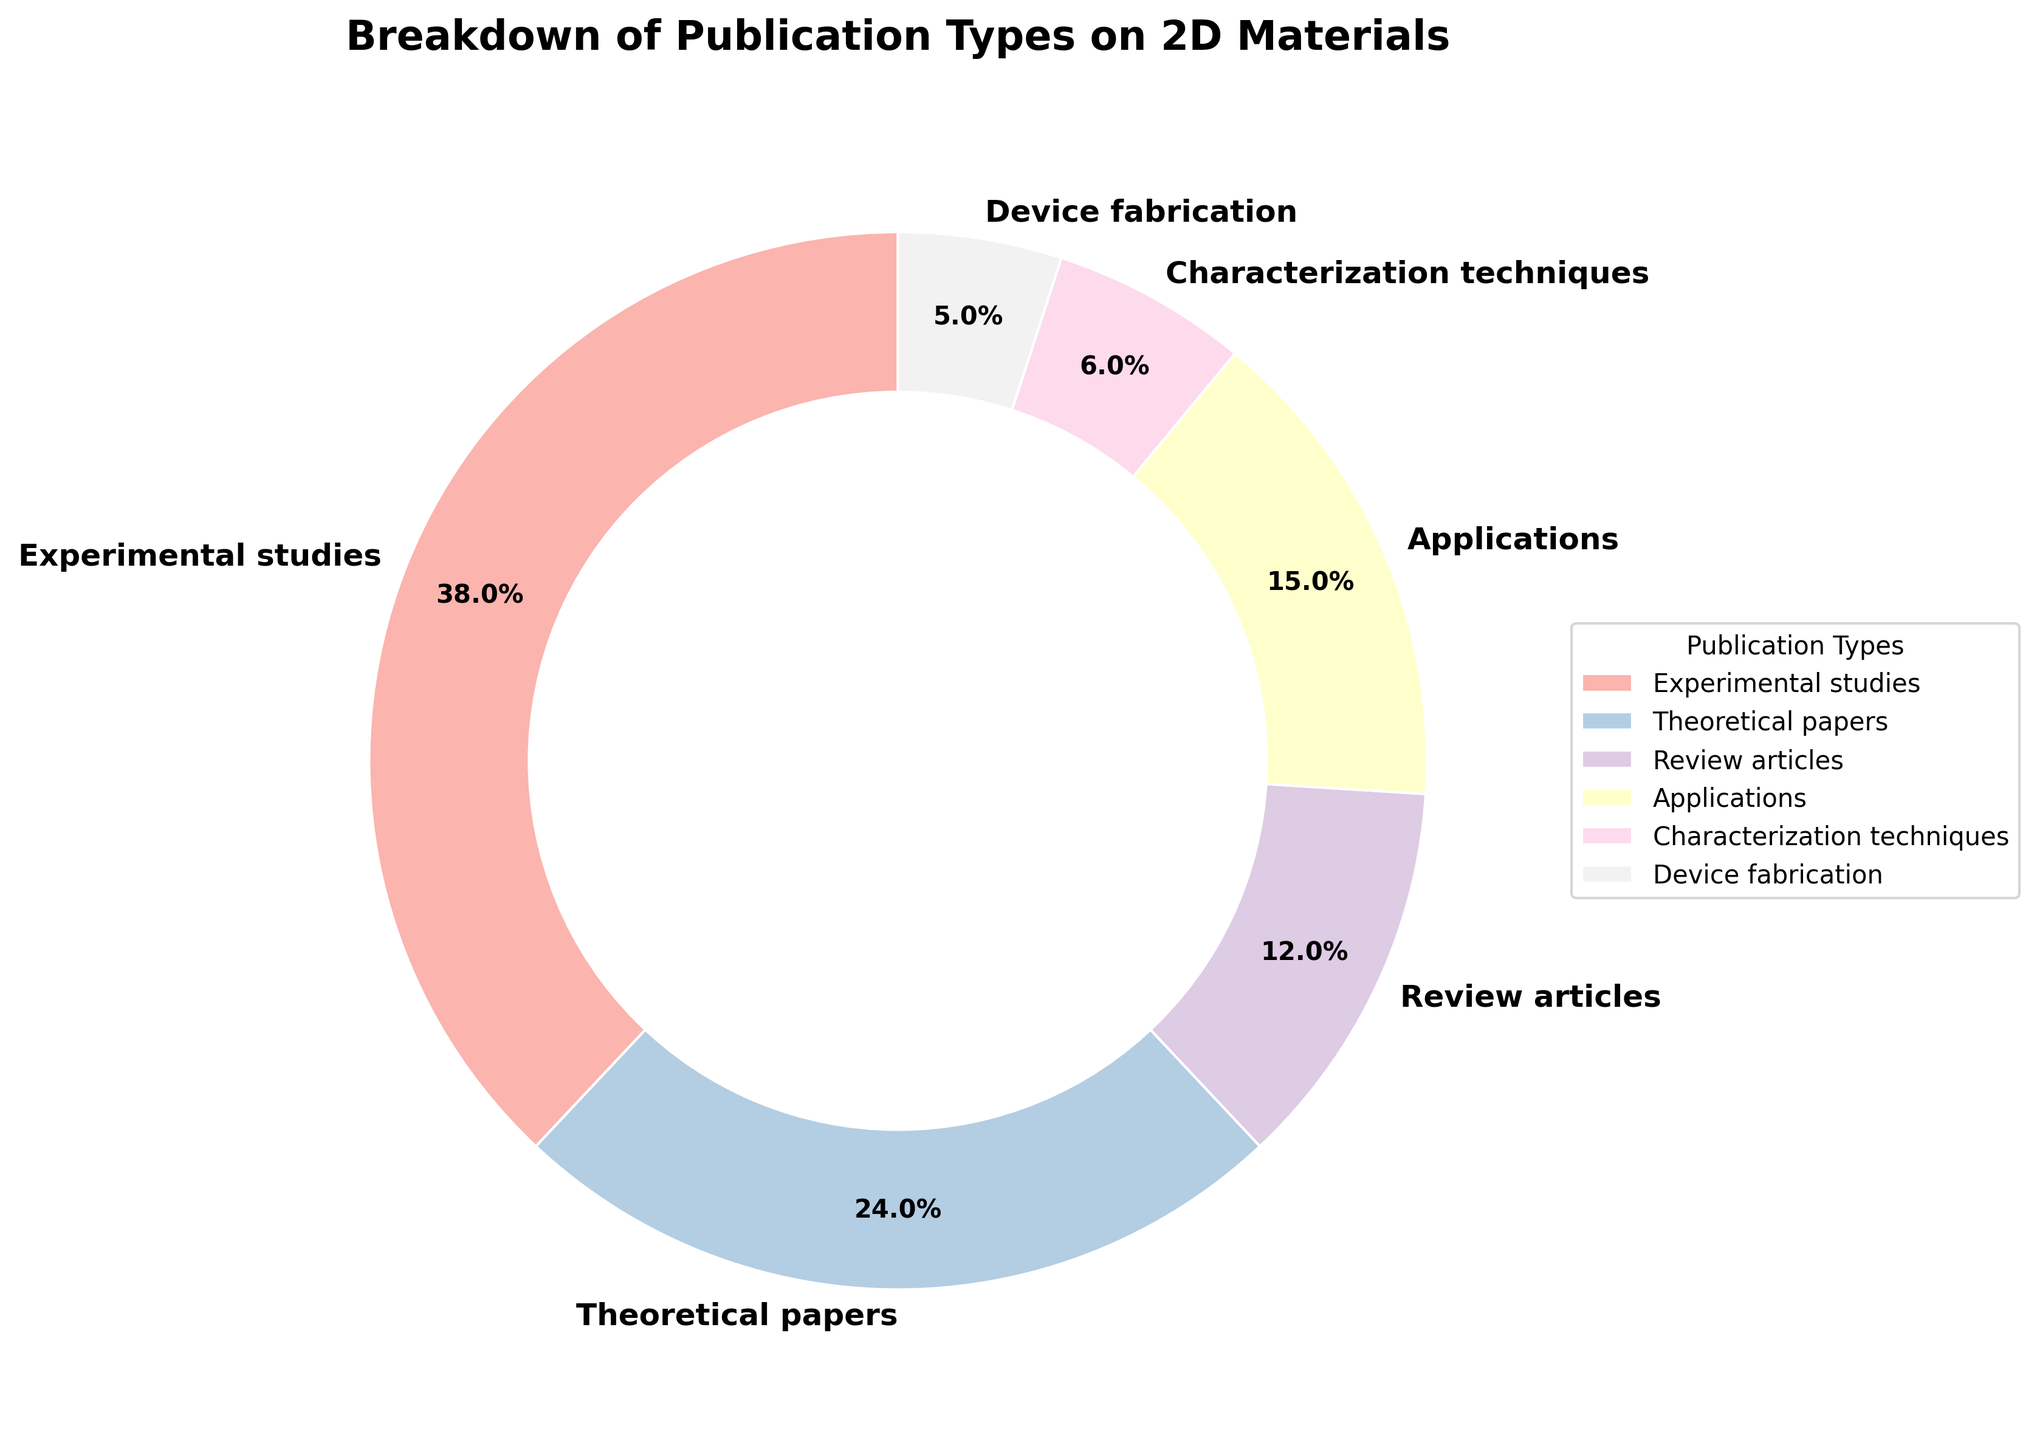What percentage of the publications are practical applications? The chart shows a segment labeled "Applications," which is 15%.
Answer: 15% Which category contributes the least to the publication types on 2D materials? By examining the pie chart segments, "Device fabrication" has the smallest segment, indicating 5%.
Answer: Device fabrication What is the combined percentage of experimental studies and theoretical papers? The percentage for "Experimental studies" is 38% and for "Theoretical papers" is 24%. Adding them gives 38% + 24% = 62%.
Answer: 62% How do the percentage of review articles compare to that of characterization techniques? The percentage for "Review articles" is 12%, and for "Characterization techniques" is 6%. 12% is double 6%.
Answer: Review articles are twice as much as characterization techniques Which type of publication has a lower percentage than applications but higher than device fabrication? "Applications" have 15% while "Device fabrication" has 5%. Between them is "Characterization techniques" with 6%.
Answer: Characterization techniques Is the combined percentage of review articles and device fabrication greater than the percentage of theoretical papers? "Review articles" are 12%, and "Device fabrication" is 5%, combined they make 12% + 5% = 17%. "Theoretical papers" are 24%. Since 17% < 24%, the combined percentage is not greater.
Answer: No What is the difference in percentage between the highest and lowest publication types? "Experimental studies" have the highest percentage at 38%, and "Device fabrication" the lowest at 5%. The difference is 38% - 5% = 33%.
Answer: 33% What percentage of publications is not either experimental studies or applications? "Experimental Studies" and "Applications" percentages are 38% and 15% respectively. Combined they are 38% + 15% = 53%. Subtracting from 100% gives 100% - 53% = 47%.
Answer: 47% Explain the segments representing experimental studies and review articles in terms of their visual appearance. The pie chart shows that the segment for "Experimental studies" is the largest one in a pastel color, while the segment for "Review articles" is smaller, also in a pastel color but visually thinner.
Answer: Experimental studies is the largest, review articles are smaller 